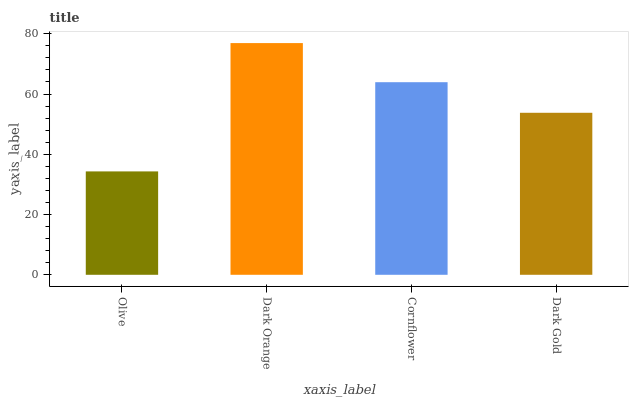Is Olive the minimum?
Answer yes or no. Yes. Is Dark Orange the maximum?
Answer yes or no. Yes. Is Cornflower the minimum?
Answer yes or no. No. Is Cornflower the maximum?
Answer yes or no. No. Is Dark Orange greater than Cornflower?
Answer yes or no. Yes. Is Cornflower less than Dark Orange?
Answer yes or no. Yes. Is Cornflower greater than Dark Orange?
Answer yes or no. No. Is Dark Orange less than Cornflower?
Answer yes or no. No. Is Cornflower the high median?
Answer yes or no. Yes. Is Dark Gold the low median?
Answer yes or no. Yes. Is Olive the high median?
Answer yes or no. No. Is Cornflower the low median?
Answer yes or no. No. 